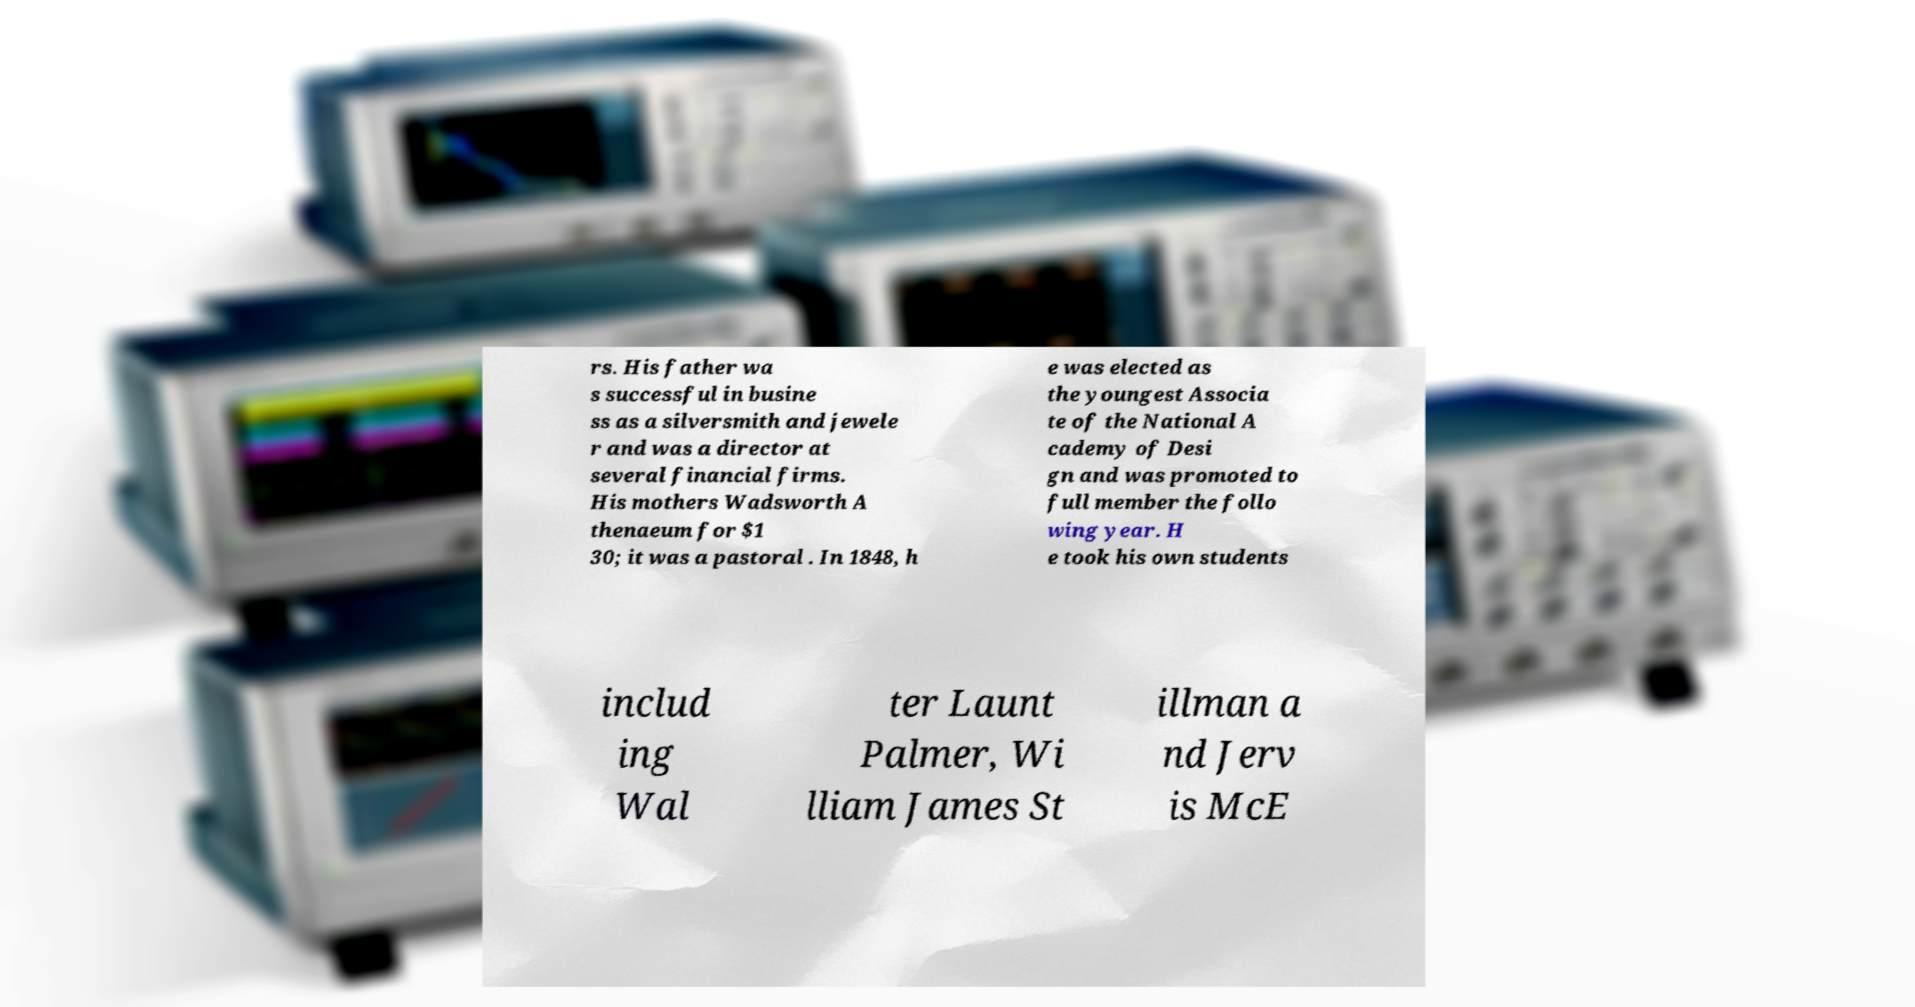Please identify and transcribe the text found in this image. rs. His father wa s successful in busine ss as a silversmith and jewele r and was a director at several financial firms. His mothers Wadsworth A thenaeum for $1 30; it was a pastoral . In 1848, h e was elected as the youngest Associa te of the National A cademy of Desi gn and was promoted to full member the follo wing year. H e took his own students includ ing Wal ter Launt Palmer, Wi lliam James St illman a nd Jerv is McE 